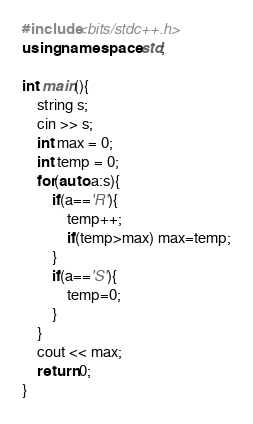<code> <loc_0><loc_0><loc_500><loc_500><_C++_>#include<bits/stdc++.h>
using namespace std;

int main(){
    string s;
    cin >> s;
    int max = 0;
    int temp = 0;
    for(auto a:s){
        if(a=='R'){
            temp++;
            if(temp>max) max=temp;
        }
        if(a=='S'){
            temp=0;
        }
    }
    cout << max; 
    return 0;
}</code> 